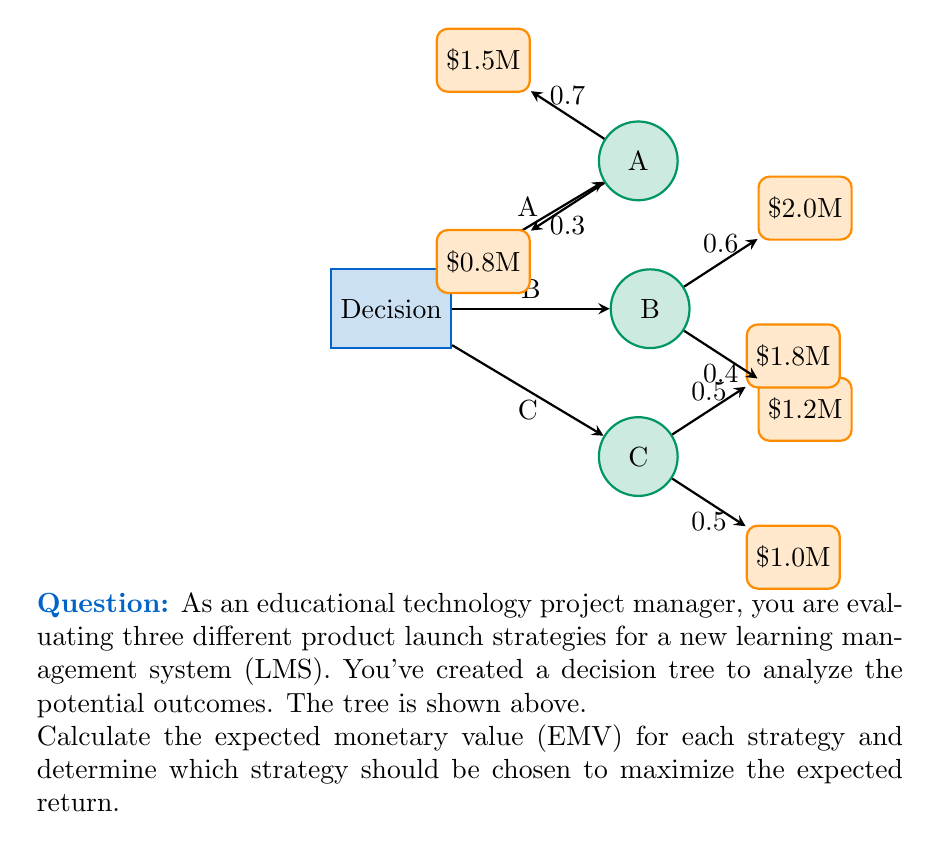Give your solution to this math problem. To solve this problem, we need to calculate the EMV for each strategy and compare them. The EMV is the sum of each possible outcome multiplied by its probability.

Strategy A:
EMV(A) = 0.7 * $1.5M + 0.3 * $0.8M
       = $1.05M + $0.24M
       = $1.29M

Strategy B:
EMV(B) = 0.6 * $2.0M + 0.4 * $1.2M
       = $1.2M + $0.48M
       = $1.68M

Strategy C:
EMV(C) = 0.5 * $1.8M + 0.5 * $1.0M
       = $0.9M + $0.5M
       = $1.4M

Now, we compare the EMVs:

$$\text{EMV(A)} = \$1.29\text{M}$$
$$\text{EMV(B)} = \$1.68\text{M}$$
$$\text{EMV(C)} = \$1.4\text{M}$$

Strategy B has the highest EMV, so it should be chosen to maximize the expected return.
Answer: Strategy B with EMV = $1.68M 